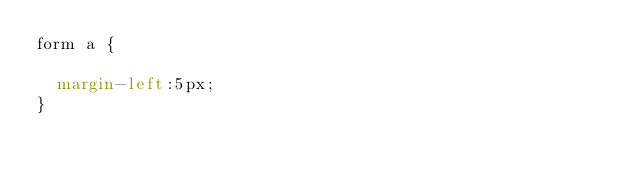Convert code to text. <code><loc_0><loc_0><loc_500><loc_500><_CSS_>form a {

	margin-left:5px;
}</code> 